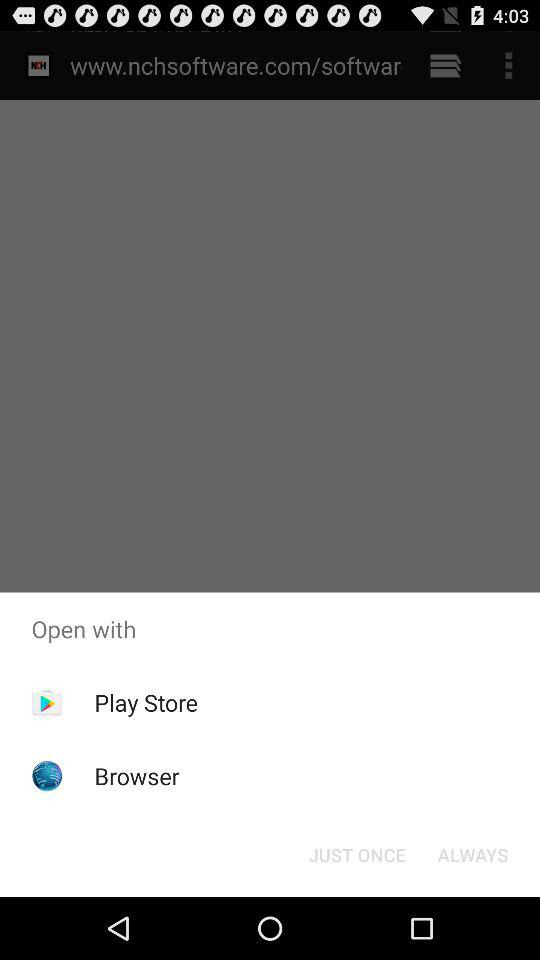What are the different options to open with? The options are "Play Store" and "Browser". 